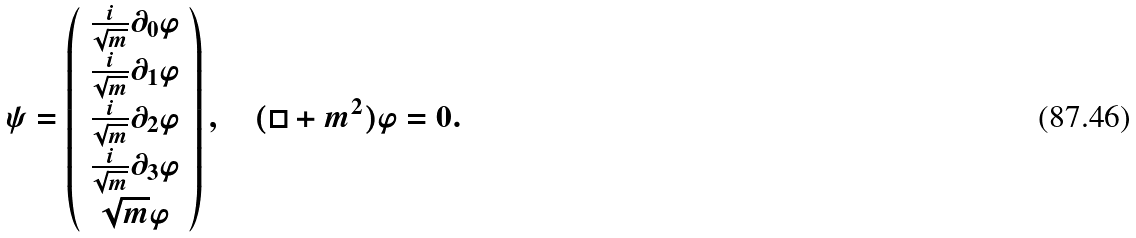<formula> <loc_0><loc_0><loc_500><loc_500>\psi = \left ( \begin{array} { c } \frac { i } { \sqrt { m } } \partial _ { 0 } \varphi \\ \frac { i } { \sqrt { m } } \partial _ { 1 } \varphi \\ \frac { i } { \sqrt { m } } \partial _ { 2 } \varphi \\ \frac { i } { \sqrt { m } } \partial _ { 3 } \varphi \\ \sqrt { m } \varphi \end{array} \right ) , \quad ( \square + m ^ { 2 } ) \varphi = 0 .</formula> 